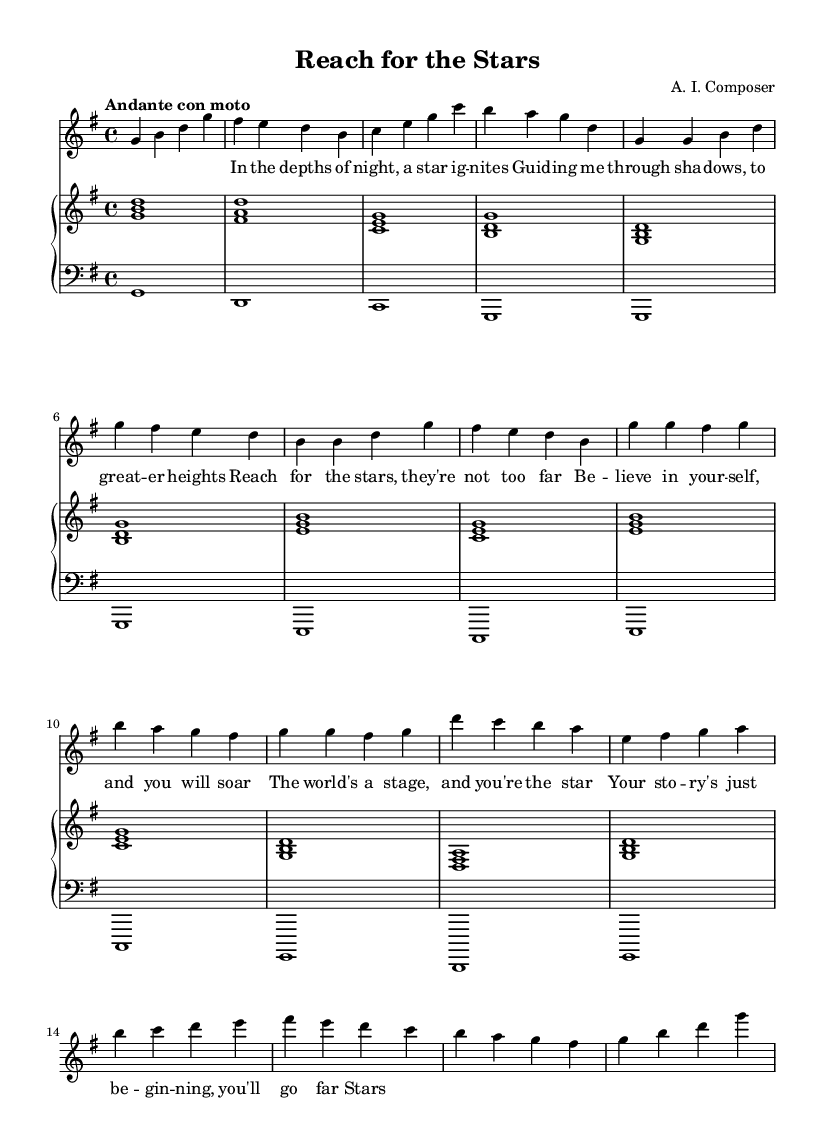What is the key signature of this music? The key signature is G major, which has one sharp (F#). This can be confirmed by looking at the beginning of the staff, where the sharp sign appears.
Answer: G major What is the time signature of this music? The time signature is 4/4, as indicated at the start of the score, showing there are four beats in each measure.
Answer: 4/4 What is the tempo marking of this music? The tempo marking is "Andante con moto," which advises a moderate pace with a slight emphasis on movement. This text is clearly stated near the top of the score.
Answer: Andante con moto How many measures are in the chorus section? The chorus section contains two measures; this can be determined by counting the separate groupings of notes in the chorus part labeled in the sheet music.
Answer: 2 What is the overall theme of the lyrics? The overall theme emphasizes encouragement and self-belief in the pursuit of dreams, as shown through the lyrics about reaching for stars and believing in oneself.
Answer: Encouragement In which section do we see the repetition of the melody? The repetition of the melody occurs during the chorus, where the same melodic phrases are sung again, indicating a common structure in operatic arias for emphasis.
Answer: Chorus What role does the bridge play in the piece? The bridge serves as a contrast to the previous sections, introducing new melodic material that leads back to the final section of the piece, enhancing the narrative of the song.
Answer: Contrast 